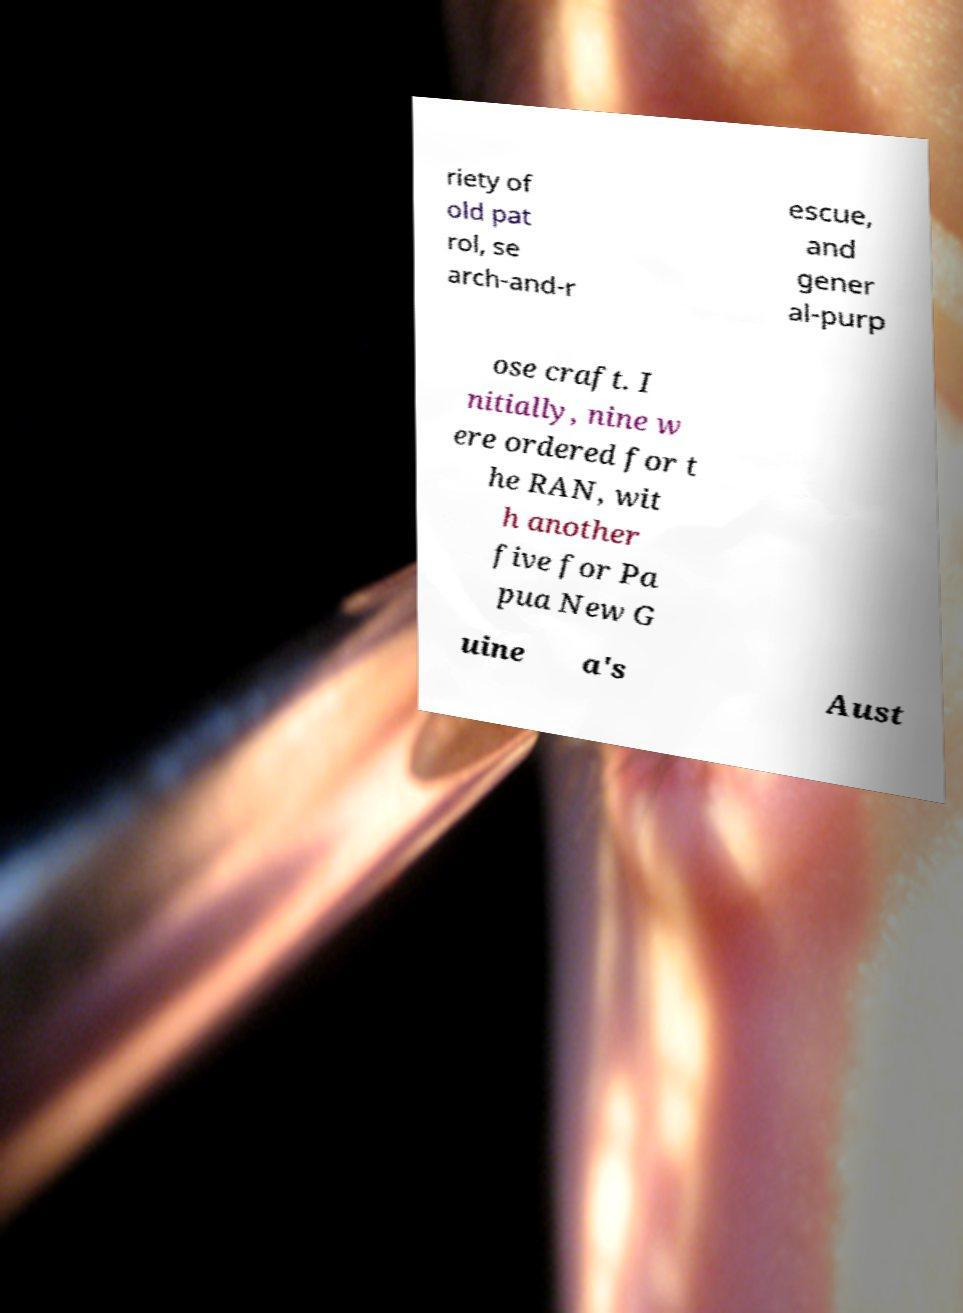Could you extract and type out the text from this image? riety of old pat rol, se arch-and-r escue, and gener al-purp ose craft. I nitially, nine w ere ordered for t he RAN, wit h another five for Pa pua New G uine a's Aust 